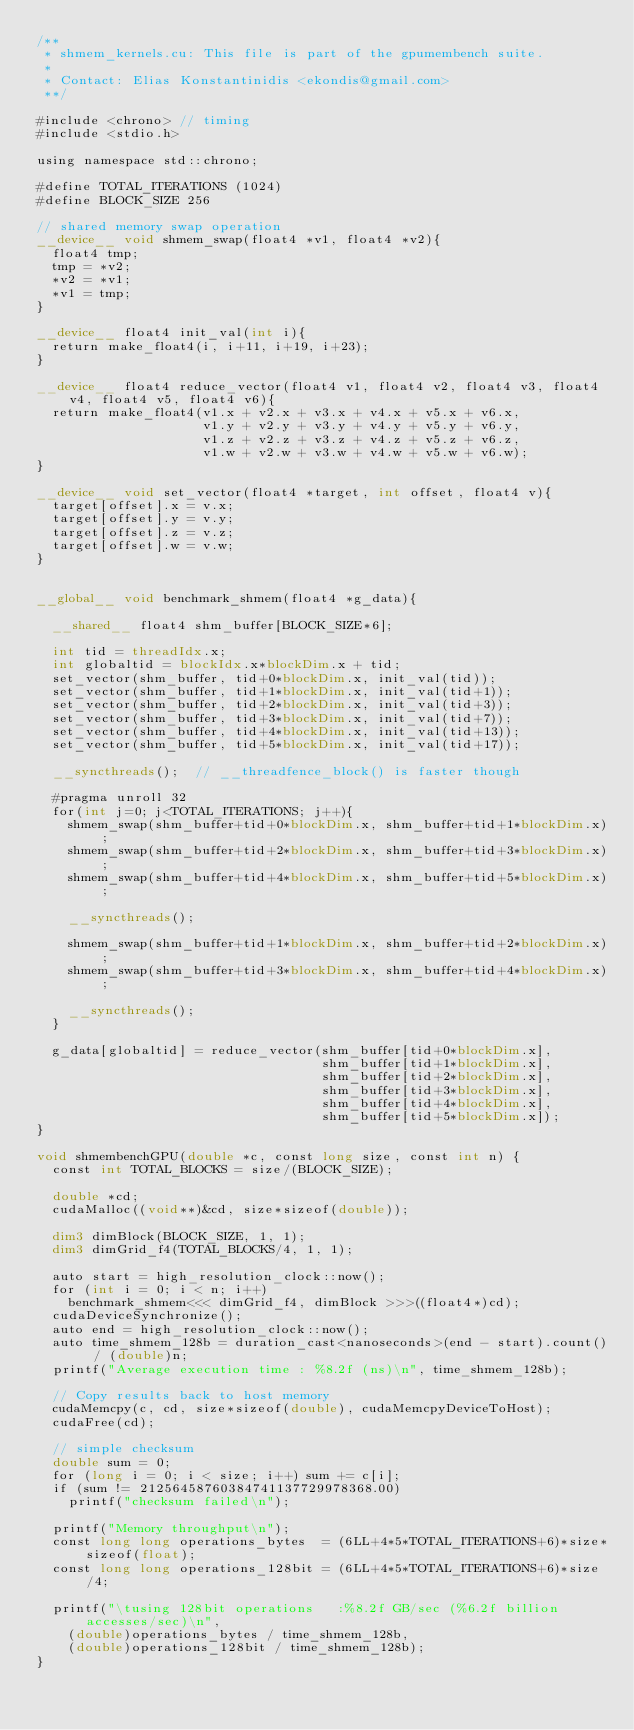Convert code to text. <code><loc_0><loc_0><loc_500><loc_500><_Cuda_>/**
 * shmem_kernels.cu: This file is part of the gpumembench suite.
 *
 * Contact: Elias Konstantinidis <ekondis@gmail.com>
 **/

#include <chrono> // timing
#include <stdio.h>

using namespace std::chrono;

#define TOTAL_ITERATIONS (1024)
#define BLOCK_SIZE 256

// shared memory swap operation
__device__ void shmem_swap(float4 *v1, float4 *v2){
  float4 tmp;
  tmp = *v2;
  *v2 = *v1;
  *v1 = tmp;
}

__device__ float4 init_val(int i){
  return make_float4(i, i+11, i+19, i+23);
}

__device__ float4 reduce_vector(float4 v1, float4 v2, float4 v3, float4 v4, float4 v5, float4 v6){
  return make_float4(v1.x + v2.x + v3.x + v4.x + v5.x + v6.x, 
                     v1.y + v2.y + v3.y + v4.y + v5.y + v6.y,
                     v1.z + v2.z + v3.z + v4.z + v5.z + v6.z,
                     v1.w + v2.w + v3.w + v4.w + v5.w + v6.w);
}

__device__ void set_vector(float4 *target, int offset, float4 v){
  target[offset].x = v.x;
  target[offset].y = v.y;
  target[offset].z = v.z;
  target[offset].w = v.w;
}


__global__ void benchmark_shmem(float4 *g_data){

  __shared__ float4 shm_buffer[BLOCK_SIZE*6];

  int tid = threadIdx.x; 
  int globaltid = blockIdx.x*blockDim.x + tid;
  set_vector(shm_buffer, tid+0*blockDim.x, init_val(tid));
  set_vector(shm_buffer, tid+1*blockDim.x, init_val(tid+1));
  set_vector(shm_buffer, tid+2*blockDim.x, init_val(tid+3));
  set_vector(shm_buffer, tid+3*blockDim.x, init_val(tid+7));
  set_vector(shm_buffer, tid+4*blockDim.x, init_val(tid+13));
  set_vector(shm_buffer, tid+5*blockDim.x, init_val(tid+17));

  __syncthreads();  // __threadfence_block() is faster though

  #pragma unroll 32
  for(int j=0; j<TOTAL_ITERATIONS; j++){
    shmem_swap(shm_buffer+tid+0*blockDim.x, shm_buffer+tid+1*blockDim.x);
    shmem_swap(shm_buffer+tid+2*blockDim.x, shm_buffer+tid+3*blockDim.x);
    shmem_swap(shm_buffer+tid+4*blockDim.x, shm_buffer+tid+5*blockDim.x);

    __syncthreads();

    shmem_swap(shm_buffer+tid+1*blockDim.x, shm_buffer+tid+2*blockDim.x);
    shmem_swap(shm_buffer+tid+3*blockDim.x, shm_buffer+tid+4*blockDim.x);

    __syncthreads();
  }

  g_data[globaltid] = reduce_vector(shm_buffer[tid+0*blockDim.x], 
                                    shm_buffer[tid+1*blockDim.x],
                                    shm_buffer[tid+2*blockDim.x],
                                    shm_buffer[tid+3*blockDim.x],
                                    shm_buffer[tid+4*blockDim.x],
                                    shm_buffer[tid+5*blockDim.x]);
}

void shmembenchGPU(double *c, const long size, const int n) {
  const int TOTAL_BLOCKS = size/(BLOCK_SIZE);

  double *cd;
  cudaMalloc((void**)&cd, size*sizeof(double));

  dim3 dimBlock(BLOCK_SIZE, 1, 1);
  dim3 dimGrid_f4(TOTAL_BLOCKS/4, 1, 1);

  auto start = high_resolution_clock::now();
  for (int i = 0; i < n; i++)
    benchmark_shmem<<< dimGrid_f4, dimBlock >>>((float4*)cd);
  cudaDeviceSynchronize();
  auto end = high_resolution_clock::now();
  auto time_shmem_128b = duration_cast<nanoseconds>(end - start).count() / (double)n;
  printf("Average execution time : %8.2f (ns)\n", time_shmem_128b);

  // Copy results back to host memory
  cudaMemcpy(c, cd, size*sizeof(double), cudaMemcpyDeviceToHost);
  cudaFree(cd);

  // simple checksum
  double sum = 0;
  for (long i = 0; i < size; i++) sum += c[i];
  if (sum != 21256458760384741137729978368.00)
    printf("checksum failed\n");
  
  printf("Memory throughput\n");
  const long long operations_bytes  = (6LL+4*5*TOTAL_ITERATIONS+6)*size*sizeof(float);
  const long long operations_128bit = (6LL+4*5*TOTAL_ITERATIONS+6)*size/4;

  printf("\tusing 128bit operations   :%8.2f GB/sec (%6.2f billion accesses/sec)\n", 
    (double)operations_bytes / time_shmem_128b,
    (double)operations_128bit / time_shmem_128b);
}
</code> 